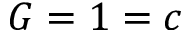<formula> <loc_0><loc_0><loc_500><loc_500>G = 1 = c</formula> 